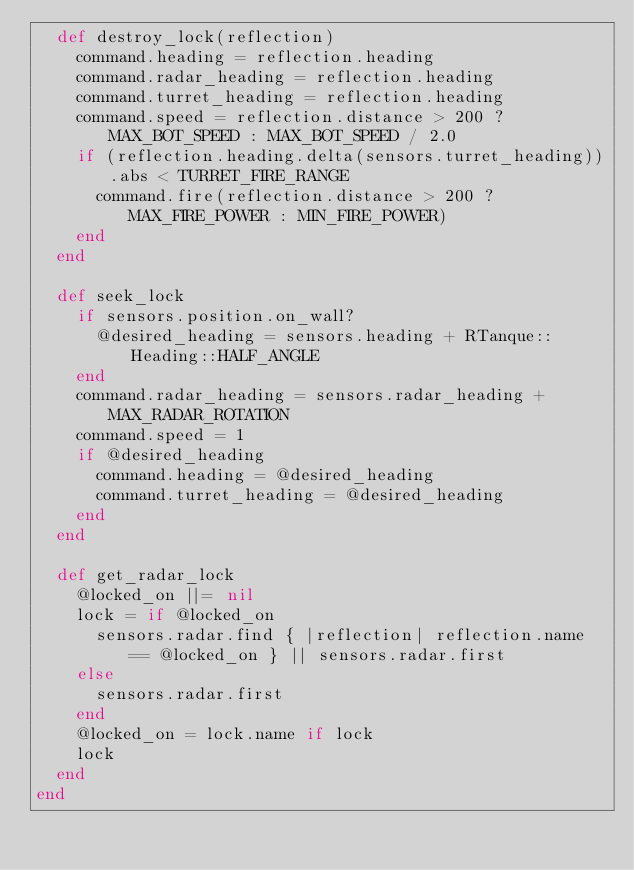<code> <loc_0><loc_0><loc_500><loc_500><_Ruby_>  def destroy_lock(reflection)
    command.heading = reflection.heading
    command.radar_heading = reflection.heading
    command.turret_heading = reflection.heading
    command.speed = reflection.distance > 200 ? MAX_BOT_SPEED : MAX_BOT_SPEED / 2.0
    if (reflection.heading.delta(sensors.turret_heading)).abs < TURRET_FIRE_RANGE
      command.fire(reflection.distance > 200 ? MAX_FIRE_POWER : MIN_FIRE_POWER)
    end
  end

  def seek_lock
    if sensors.position.on_wall?
      @desired_heading = sensors.heading + RTanque::Heading::HALF_ANGLE
    end
    command.radar_heading = sensors.radar_heading + MAX_RADAR_ROTATION
    command.speed = 1
    if @desired_heading
      command.heading = @desired_heading
      command.turret_heading = @desired_heading
    end
  end

  def get_radar_lock
    @locked_on ||= nil
    lock = if @locked_on
      sensors.radar.find { |reflection| reflection.name == @locked_on } || sensors.radar.first
    else
      sensors.radar.first
    end
    @locked_on = lock.name if lock
    lock
  end
end
</code> 